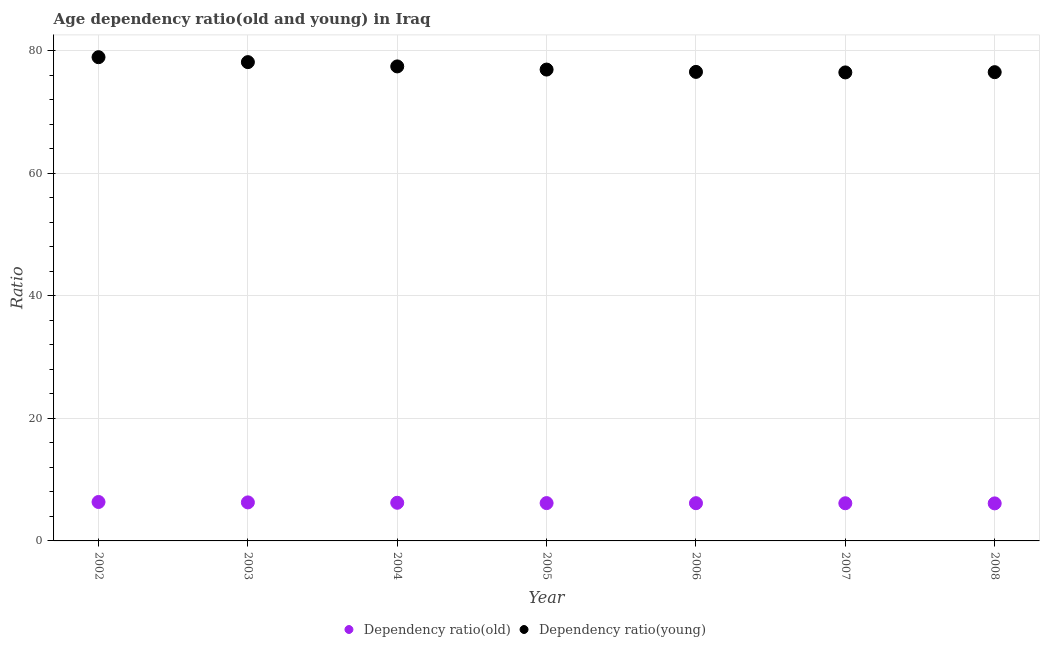How many different coloured dotlines are there?
Make the answer very short. 2. Is the number of dotlines equal to the number of legend labels?
Ensure brevity in your answer.  Yes. What is the age dependency ratio(old) in 2002?
Give a very brief answer. 6.35. Across all years, what is the maximum age dependency ratio(old)?
Your answer should be compact. 6.35. Across all years, what is the minimum age dependency ratio(young)?
Give a very brief answer. 76.47. In which year was the age dependency ratio(young) minimum?
Your answer should be very brief. 2007. What is the total age dependency ratio(young) in the graph?
Offer a very short reply. 541.01. What is the difference between the age dependency ratio(old) in 2005 and that in 2007?
Offer a very short reply. 0.03. What is the difference between the age dependency ratio(young) in 2002 and the age dependency ratio(old) in 2004?
Ensure brevity in your answer.  72.73. What is the average age dependency ratio(old) per year?
Offer a terse response. 6.21. In the year 2005, what is the difference between the age dependency ratio(old) and age dependency ratio(young)?
Offer a very short reply. -70.76. In how many years, is the age dependency ratio(young) greater than 72?
Provide a short and direct response. 7. What is the ratio of the age dependency ratio(young) in 2007 to that in 2008?
Make the answer very short. 1. Is the age dependency ratio(old) in 2003 less than that in 2006?
Offer a very short reply. No. What is the difference between the highest and the second highest age dependency ratio(young)?
Ensure brevity in your answer.  0.81. What is the difference between the highest and the lowest age dependency ratio(young)?
Your answer should be compact. 2.49. In how many years, is the age dependency ratio(old) greater than the average age dependency ratio(old) taken over all years?
Offer a terse response. 3. Does the age dependency ratio(young) monotonically increase over the years?
Make the answer very short. No. Is the age dependency ratio(old) strictly less than the age dependency ratio(young) over the years?
Keep it short and to the point. Yes. How many years are there in the graph?
Provide a short and direct response. 7. What is the difference between two consecutive major ticks on the Y-axis?
Offer a terse response. 20. Does the graph contain any zero values?
Make the answer very short. No. Does the graph contain grids?
Offer a very short reply. Yes. How many legend labels are there?
Make the answer very short. 2. What is the title of the graph?
Offer a very short reply. Age dependency ratio(old and young) in Iraq. Does "Old" appear as one of the legend labels in the graph?
Offer a very short reply. No. What is the label or title of the Y-axis?
Your answer should be very brief. Ratio. What is the Ratio in Dependency ratio(old) in 2002?
Provide a succinct answer. 6.35. What is the Ratio of Dependency ratio(young) in 2002?
Offer a very short reply. 78.95. What is the Ratio of Dependency ratio(old) in 2003?
Keep it short and to the point. 6.29. What is the Ratio of Dependency ratio(young) in 2003?
Provide a short and direct response. 78.15. What is the Ratio of Dependency ratio(old) in 2004?
Your answer should be compact. 6.23. What is the Ratio in Dependency ratio(young) in 2004?
Provide a short and direct response. 77.45. What is the Ratio of Dependency ratio(old) in 2005?
Your answer should be very brief. 6.17. What is the Ratio of Dependency ratio(young) in 2005?
Your answer should be very brief. 76.93. What is the Ratio in Dependency ratio(old) in 2006?
Offer a terse response. 6.16. What is the Ratio in Dependency ratio(young) in 2006?
Make the answer very short. 76.55. What is the Ratio in Dependency ratio(old) in 2007?
Your response must be concise. 6.15. What is the Ratio in Dependency ratio(young) in 2007?
Offer a terse response. 76.47. What is the Ratio in Dependency ratio(old) in 2008?
Your answer should be very brief. 6.13. What is the Ratio in Dependency ratio(young) in 2008?
Give a very brief answer. 76.51. Across all years, what is the maximum Ratio of Dependency ratio(old)?
Give a very brief answer. 6.35. Across all years, what is the maximum Ratio of Dependency ratio(young)?
Ensure brevity in your answer.  78.95. Across all years, what is the minimum Ratio in Dependency ratio(old)?
Provide a succinct answer. 6.13. Across all years, what is the minimum Ratio in Dependency ratio(young)?
Give a very brief answer. 76.47. What is the total Ratio in Dependency ratio(old) in the graph?
Give a very brief answer. 43.48. What is the total Ratio of Dependency ratio(young) in the graph?
Ensure brevity in your answer.  541.01. What is the difference between the Ratio in Dependency ratio(old) in 2002 and that in 2003?
Your answer should be very brief. 0.07. What is the difference between the Ratio in Dependency ratio(young) in 2002 and that in 2003?
Your answer should be compact. 0.81. What is the difference between the Ratio in Dependency ratio(old) in 2002 and that in 2004?
Make the answer very short. 0.13. What is the difference between the Ratio of Dependency ratio(young) in 2002 and that in 2004?
Offer a terse response. 1.51. What is the difference between the Ratio in Dependency ratio(old) in 2002 and that in 2005?
Make the answer very short. 0.18. What is the difference between the Ratio of Dependency ratio(young) in 2002 and that in 2005?
Your answer should be compact. 2.02. What is the difference between the Ratio in Dependency ratio(old) in 2002 and that in 2006?
Keep it short and to the point. 0.2. What is the difference between the Ratio in Dependency ratio(young) in 2002 and that in 2006?
Make the answer very short. 2.4. What is the difference between the Ratio in Dependency ratio(old) in 2002 and that in 2007?
Your answer should be very brief. 0.21. What is the difference between the Ratio in Dependency ratio(young) in 2002 and that in 2007?
Your answer should be compact. 2.49. What is the difference between the Ratio of Dependency ratio(old) in 2002 and that in 2008?
Offer a very short reply. 0.23. What is the difference between the Ratio of Dependency ratio(young) in 2002 and that in 2008?
Keep it short and to the point. 2.45. What is the difference between the Ratio in Dependency ratio(old) in 2003 and that in 2004?
Give a very brief answer. 0.06. What is the difference between the Ratio in Dependency ratio(young) in 2003 and that in 2004?
Your answer should be very brief. 0.7. What is the difference between the Ratio in Dependency ratio(old) in 2003 and that in 2005?
Provide a short and direct response. 0.11. What is the difference between the Ratio of Dependency ratio(young) in 2003 and that in 2005?
Your answer should be very brief. 1.21. What is the difference between the Ratio of Dependency ratio(old) in 2003 and that in 2006?
Give a very brief answer. 0.13. What is the difference between the Ratio of Dependency ratio(young) in 2003 and that in 2006?
Keep it short and to the point. 1.59. What is the difference between the Ratio in Dependency ratio(old) in 2003 and that in 2007?
Your answer should be compact. 0.14. What is the difference between the Ratio of Dependency ratio(young) in 2003 and that in 2007?
Offer a terse response. 1.68. What is the difference between the Ratio in Dependency ratio(old) in 2003 and that in 2008?
Provide a short and direct response. 0.16. What is the difference between the Ratio of Dependency ratio(young) in 2003 and that in 2008?
Your response must be concise. 1.64. What is the difference between the Ratio of Dependency ratio(old) in 2004 and that in 2005?
Your response must be concise. 0.05. What is the difference between the Ratio of Dependency ratio(young) in 2004 and that in 2005?
Keep it short and to the point. 0.51. What is the difference between the Ratio in Dependency ratio(old) in 2004 and that in 2006?
Keep it short and to the point. 0.07. What is the difference between the Ratio of Dependency ratio(young) in 2004 and that in 2006?
Ensure brevity in your answer.  0.89. What is the difference between the Ratio of Dependency ratio(old) in 2004 and that in 2007?
Offer a very short reply. 0.08. What is the difference between the Ratio of Dependency ratio(young) in 2004 and that in 2007?
Keep it short and to the point. 0.98. What is the difference between the Ratio of Dependency ratio(old) in 2004 and that in 2008?
Your answer should be compact. 0.1. What is the difference between the Ratio of Dependency ratio(young) in 2004 and that in 2008?
Make the answer very short. 0.94. What is the difference between the Ratio in Dependency ratio(old) in 2005 and that in 2006?
Offer a very short reply. 0.01. What is the difference between the Ratio of Dependency ratio(young) in 2005 and that in 2006?
Offer a very short reply. 0.38. What is the difference between the Ratio of Dependency ratio(old) in 2005 and that in 2007?
Make the answer very short. 0.03. What is the difference between the Ratio in Dependency ratio(young) in 2005 and that in 2007?
Your response must be concise. 0.47. What is the difference between the Ratio in Dependency ratio(old) in 2005 and that in 2008?
Your answer should be very brief. 0.05. What is the difference between the Ratio of Dependency ratio(young) in 2005 and that in 2008?
Your answer should be compact. 0.42. What is the difference between the Ratio in Dependency ratio(old) in 2006 and that in 2007?
Your answer should be very brief. 0.01. What is the difference between the Ratio of Dependency ratio(young) in 2006 and that in 2007?
Provide a succinct answer. 0.09. What is the difference between the Ratio in Dependency ratio(old) in 2006 and that in 2008?
Give a very brief answer. 0.03. What is the difference between the Ratio of Dependency ratio(young) in 2006 and that in 2008?
Provide a short and direct response. 0.05. What is the difference between the Ratio in Dependency ratio(old) in 2007 and that in 2008?
Provide a succinct answer. 0.02. What is the difference between the Ratio of Dependency ratio(young) in 2007 and that in 2008?
Keep it short and to the point. -0.04. What is the difference between the Ratio in Dependency ratio(old) in 2002 and the Ratio in Dependency ratio(young) in 2003?
Your response must be concise. -71.79. What is the difference between the Ratio of Dependency ratio(old) in 2002 and the Ratio of Dependency ratio(young) in 2004?
Your answer should be very brief. -71.09. What is the difference between the Ratio of Dependency ratio(old) in 2002 and the Ratio of Dependency ratio(young) in 2005?
Provide a short and direct response. -70.58. What is the difference between the Ratio of Dependency ratio(old) in 2002 and the Ratio of Dependency ratio(young) in 2006?
Your answer should be very brief. -70.2. What is the difference between the Ratio of Dependency ratio(old) in 2002 and the Ratio of Dependency ratio(young) in 2007?
Offer a very short reply. -70.11. What is the difference between the Ratio of Dependency ratio(old) in 2002 and the Ratio of Dependency ratio(young) in 2008?
Keep it short and to the point. -70.15. What is the difference between the Ratio in Dependency ratio(old) in 2003 and the Ratio in Dependency ratio(young) in 2004?
Ensure brevity in your answer.  -71.16. What is the difference between the Ratio of Dependency ratio(old) in 2003 and the Ratio of Dependency ratio(young) in 2005?
Offer a terse response. -70.64. What is the difference between the Ratio of Dependency ratio(old) in 2003 and the Ratio of Dependency ratio(young) in 2006?
Your answer should be compact. -70.26. What is the difference between the Ratio of Dependency ratio(old) in 2003 and the Ratio of Dependency ratio(young) in 2007?
Keep it short and to the point. -70.18. What is the difference between the Ratio in Dependency ratio(old) in 2003 and the Ratio in Dependency ratio(young) in 2008?
Provide a succinct answer. -70.22. What is the difference between the Ratio in Dependency ratio(old) in 2004 and the Ratio in Dependency ratio(young) in 2005?
Your response must be concise. -70.71. What is the difference between the Ratio in Dependency ratio(old) in 2004 and the Ratio in Dependency ratio(young) in 2006?
Your response must be concise. -70.33. What is the difference between the Ratio in Dependency ratio(old) in 2004 and the Ratio in Dependency ratio(young) in 2007?
Offer a terse response. -70.24. What is the difference between the Ratio in Dependency ratio(old) in 2004 and the Ratio in Dependency ratio(young) in 2008?
Keep it short and to the point. -70.28. What is the difference between the Ratio of Dependency ratio(old) in 2005 and the Ratio of Dependency ratio(young) in 2006?
Make the answer very short. -70.38. What is the difference between the Ratio in Dependency ratio(old) in 2005 and the Ratio in Dependency ratio(young) in 2007?
Keep it short and to the point. -70.29. What is the difference between the Ratio of Dependency ratio(old) in 2005 and the Ratio of Dependency ratio(young) in 2008?
Give a very brief answer. -70.33. What is the difference between the Ratio of Dependency ratio(old) in 2006 and the Ratio of Dependency ratio(young) in 2007?
Keep it short and to the point. -70.31. What is the difference between the Ratio of Dependency ratio(old) in 2006 and the Ratio of Dependency ratio(young) in 2008?
Offer a very short reply. -70.35. What is the difference between the Ratio in Dependency ratio(old) in 2007 and the Ratio in Dependency ratio(young) in 2008?
Offer a terse response. -70.36. What is the average Ratio in Dependency ratio(old) per year?
Ensure brevity in your answer.  6.21. What is the average Ratio of Dependency ratio(young) per year?
Ensure brevity in your answer.  77.29. In the year 2002, what is the difference between the Ratio in Dependency ratio(old) and Ratio in Dependency ratio(young)?
Offer a very short reply. -72.6. In the year 2003, what is the difference between the Ratio of Dependency ratio(old) and Ratio of Dependency ratio(young)?
Keep it short and to the point. -71.86. In the year 2004, what is the difference between the Ratio of Dependency ratio(old) and Ratio of Dependency ratio(young)?
Your response must be concise. -71.22. In the year 2005, what is the difference between the Ratio in Dependency ratio(old) and Ratio in Dependency ratio(young)?
Your answer should be compact. -70.76. In the year 2006, what is the difference between the Ratio of Dependency ratio(old) and Ratio of Dependency ratio(young)?
Keep it short and to the point. -70.39. In the year 2007, what is the difference between the Ratio in Dependency ratio(old) and Ratio in Dependency ratio(young)?
Offer a very short reply. -70.32. In the year 2008, what is the difference between the Ratio of Dependency ratio(old) and Ratio of Dependency ratio(young)?
Provide a succinct answer. -70.38. What is the ratio of the Ratio in Dependency ratio(old) in 2002 to that in 2003?
Offer a terse response. 1.01. What is the ratio of the Ratio in Dependency ratio(young) in 2002 to that in 2003?
Ensure brevity in your answer.  1.01. What is the ratio of the Ratio of Dependency ratio(old) in 2002 to that in 2004?
Ensure brevity in your answer.  1.02. What is the ratio of the Ratio of Dependency ratio(young) in 2002 to that in 2004?
Your answer should be compact. 1.02. What is the ratio of the Ratio in Dependency ratio(old) in 2002 to that in 2005?
Your answer should be compact. 1.03. What is the ratio of the Ratio in Dependency ratio(young) in 2002 to that in 2005?
Offer a very short reply. 1.03. What is the ratio of the Ratio of Dependency ratio(old) in 2002 to that in 2006?
Make the answer very short. 1.03. What is the ratio of the Ratio of Dependency ratio(young) in 2002 to that in 2006?
Your response must be concise. 1.03. What is the ratio of the Ratio of Dependency ratio(old) in 2002 to that in 2007?
Your answer should be very brief. 1.03. What is the ratio of the Ratio of Dependency ratio(young) in 2002 to that in 2007?
Make the answer very short. 1.03. What is the ratio of the Ratio in Dependency ratio(old) in 2002 to that in 2008?
Make the answer very short. 1.04. What is the ratio of the Ratio of Dependency ratio(young) in 2002 to that in 2008?
Provide a short and direct response. 1.03. What is the ratio of the Ratio in Dependency ratio(old) in 2003 to that in 2004?
Ensure brevity in your answer.  1.01. What is the ratio of the Ratio of Dependency ratio(young) in 2003 to that in 2004?
Provide a short and direct response. 1.01. What is the ratio of the Ratio of Dependency ratio(old) in 2003 to that in 2005?
Your answer should be very brief. 1.02. What is the ratio of the Ratio of Dependency ratio(young) in 2003 to that in 2005?
Your answer should be very brief. 1.02. What is the ratio of the Ratio in Dependency ratio(old) in 2003 to that in 2006?
Offer a terse response. 1.02. What is the ratio of the Ratio in Dependency ratio(young) in 2003 to that in 2006?
Your answer should be very brief. 1.02. What is the ratio of the Ratio in Dependency ratio(old) in 2003 to that in 2007?
Ensure brevity in your answer.  1.02. What is the ratio of the Ratio of Dependency ratio(old) in 2003 to that in 2008?
Provide a short and direct response. 1.03. What is the ratio of the Ratio of Dependency ratio(young) in 2003 to that in 2008?
Provide a short and direct response. 1.02. What is the ratio of the Ratio of Dependency ratio(old) in 2004 to that in 2005?
Your response must be concise. 1.01. What is the ratio of the Ratio in Dependency ratio(old) in 2004 to that in 2006?
Provide a succinct answer. 1.01. What is the ratio of the Ratio of Dependency ratio(young) in 2004 to that in 2006?
Your response must be concise. 1.01. What is the ratio of the Ratio in Dependency ratio(old) in 2004 to that in 2007?
Offer a terse response. 1.01. What is the ratio of the Ratio of Dependency ratio(young) in 2004 to that in 2007?
Provide a succinct answer. 1.01. What is the ratio of the Ratio in Dependency ratio(old) in 2004 to that in 2008?
Provide a short and direct response. 1.02. What is the ratio of the Ratio in Dependency ratio(young) in 2004 to that in 2008?
Your answer should be very brief. 1.01. What is the ratio of the Ratio of Dependency ratio(old) in 2005 to that in 2007?
Provide a succinct answer. 1. What is the ratio of the Ratio in Dependency ratio(young) in 2005 to that in 2007?
Your response must be concise. 1.01. What is the ratio of the Ratio of Dependency ratio(old) in 2005 to that in 2008?
Offer a terse response. 1.01. What is the ratio of the Ratio in Dependency ratio(young) in 2005 to that in 2008?
Your answer should be very brief. 1.01. What is the ratio of the Ratio in Dependency ratio(old) in 2006 to that in 2007?
Offer a terse response. 1. What is the ratio of the Ratio in Dependency ratio(young) in 2006 to that in 2007?
Your response must be concise. 1. What is the ratio of the Ratio of Dependency ratio(young) in 2006 to that in 2008?
Your answer should be very brief. 1. What is the difference between the highest and the second highest Ratio in Dependency ratio(old)?
Provide a short and direct response. 0.07. What is the difference between the highest and the second highest Ratio of Dependency ratio(young)?
Your answer should be very brief. 0.81. What is the difference between the highest and the lowest Ratio of Dependency ratio(old)?
Provide a short and direct response. 0.23. What is the difference between the highest and the lowest Ratio in Dependency ratio(young)?
Keep it short and to the point. 2.49. 